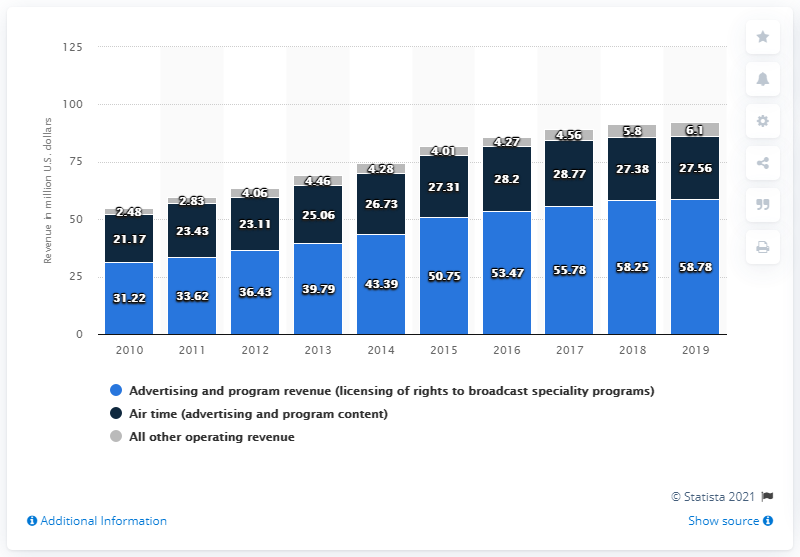What was the highest number in 2018? The highest number shown in the bar chart for 2018 is for 'All other operating revenue,' totaling approximately 58.78 million U.S. dollars. 